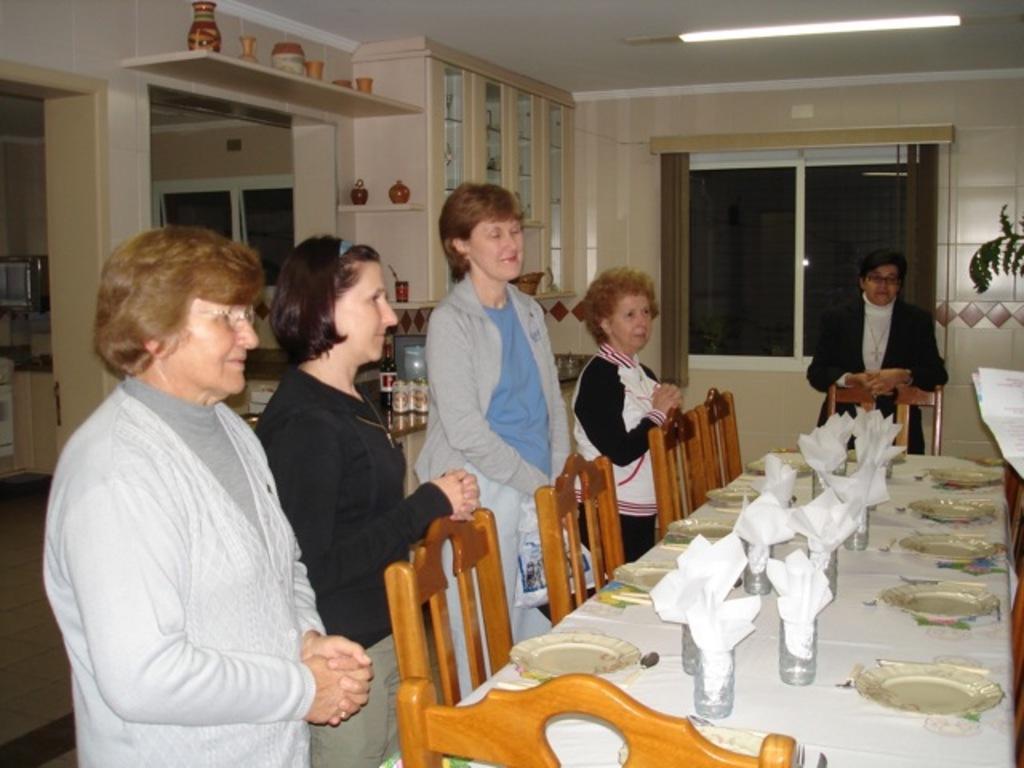How would you summarize this image in a sentence or two? The image looks like it is clicked inside the house in the dining hall. There are five persons around the dining table. There are many plates and glasses along with tissues on the dining table. To the left the woman is wearing gray color jacket. In the background there is a cupboard with some crockery. To the write there is a window along with curtain. 